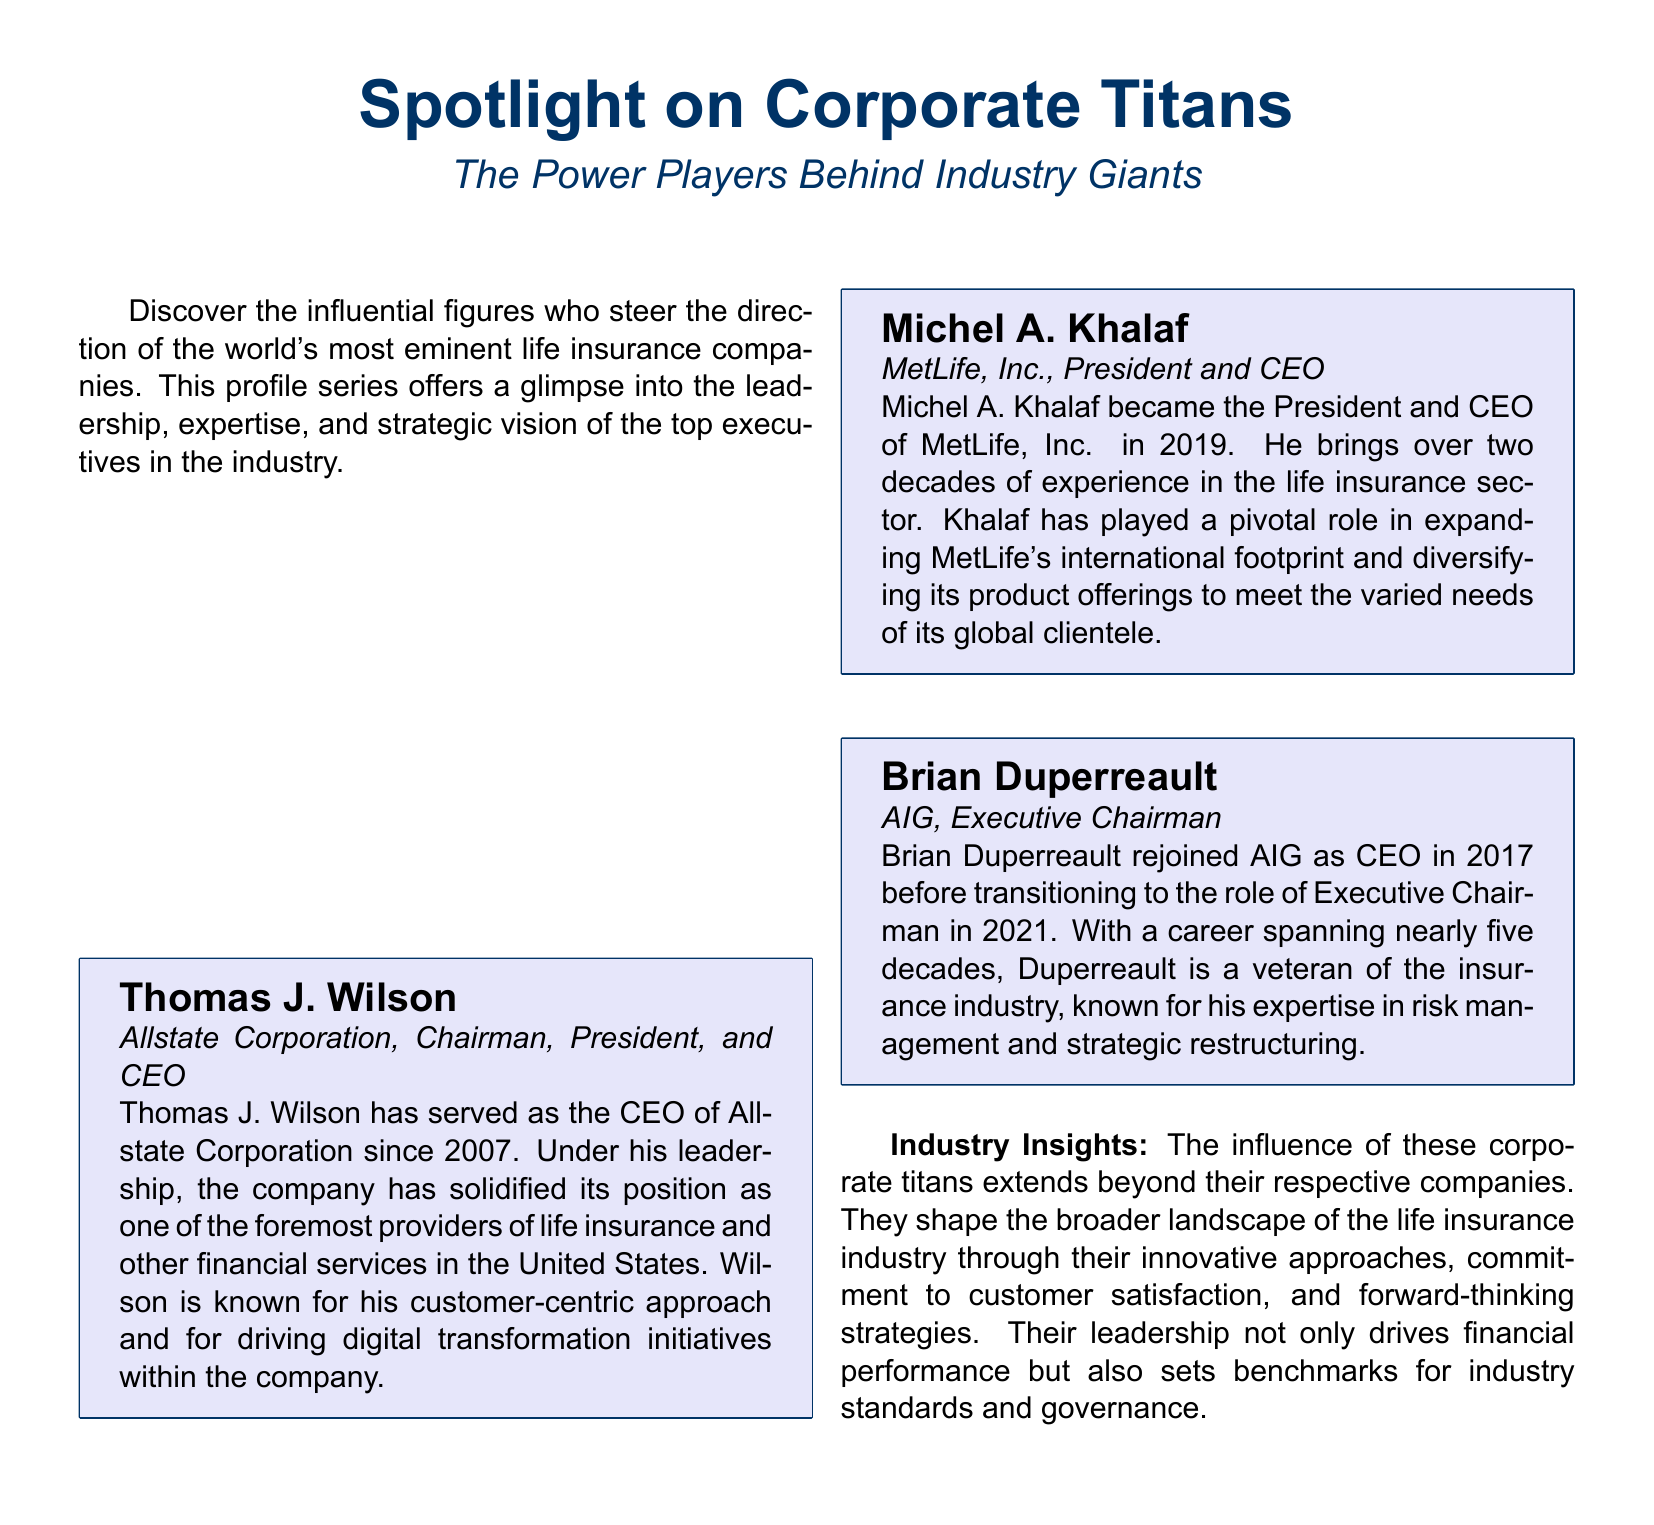What is the title of the magazine article? The title is prominently displayed at the top of the document.
Answer: Spotlight on Corporate Titans Who is the CEO of Allstate Corporation? The CEO is listed in the executive profiles section of the document.
Answer: Thomas J. Wilson In what year did Michel A. Khalaf become President and CEO of MetLife, Inc.? The specific year is mentioned in the profile of Michel A. Khalaf.
Answer: 2019 What is Brian Duperreault's current position at AIG? His current position is listed in his executive profile.
Answer: Executive Chairman How many decades of experience does Michel A. Khalaf have in the life insurance sector? The document states the number of decades in his profile.
Answer: Two decades What major change did Thomas J. Wilson drive at Allstate Corporation? His contributions to the company include specific changes noted in his profile.
Answer: Digital transformation Which company does Brian Duperreault have a career spanning nearly five decades in? The company he is associated with is given in his profile.
Answer: AIG What insight does the document provide on the influence of corporate titans? The insights relate to the broader impact of their leadership as described in the last section.
Answer: They shape the broader landscape What color is used for the box background in executive profiles? The color is specified in the document’s formatting details.
Answer: Light purple 